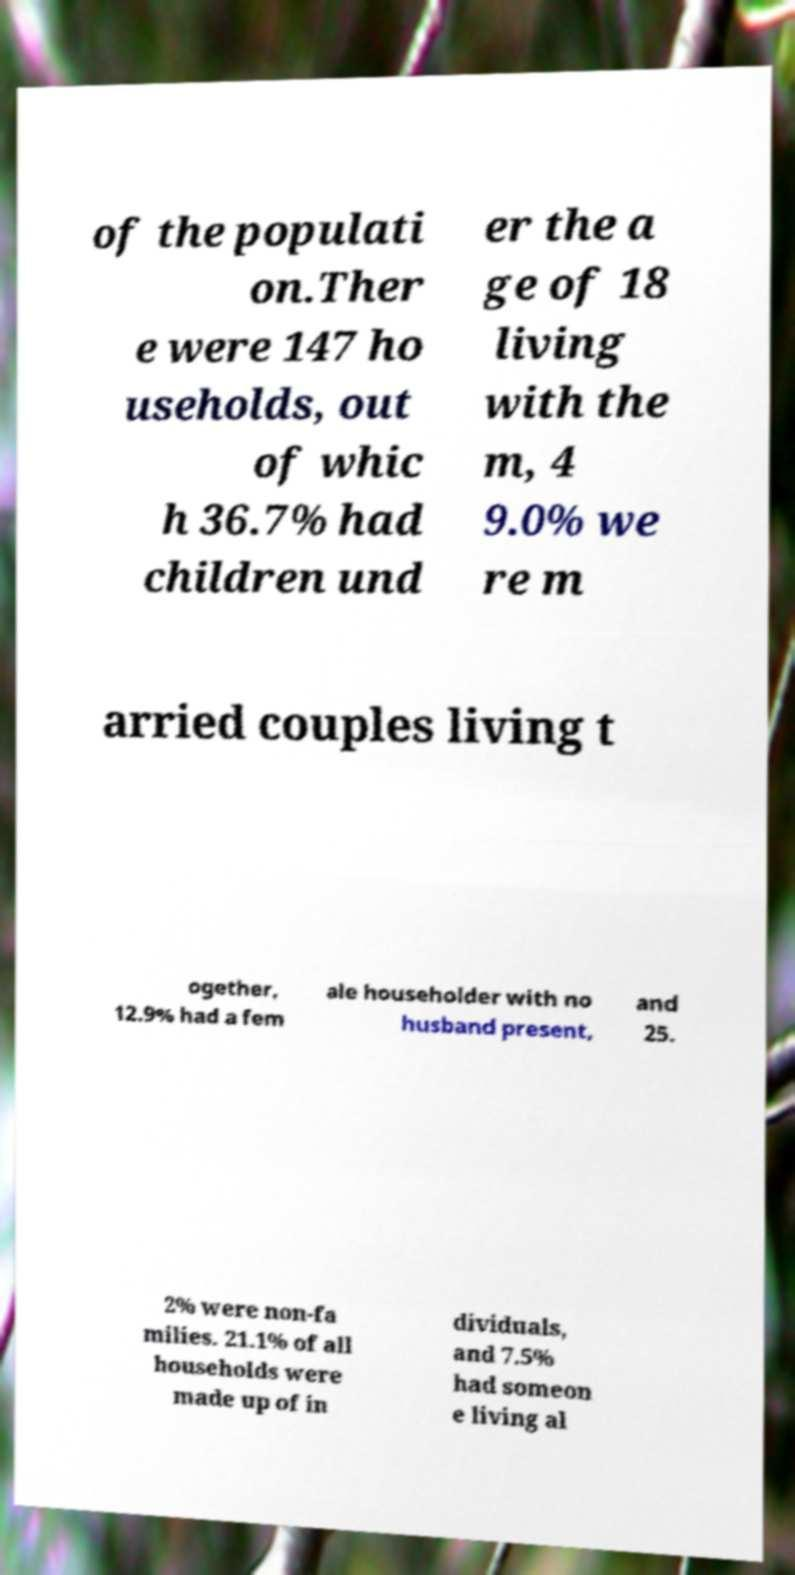Please identify and transcribe the text found in this image. of the populati on.Ther e were 147 ho useholds, out of whic h 36.7% had children und er the a ge of 18 living with the m, 4 9.0% we re m arried couples living t ogether, 12.9% had a fem ale householder with no husband present, and 25. 2% were non-fa milies. 21.1% of all households were made up of in dividuals, and 7.5% had someon e living al 